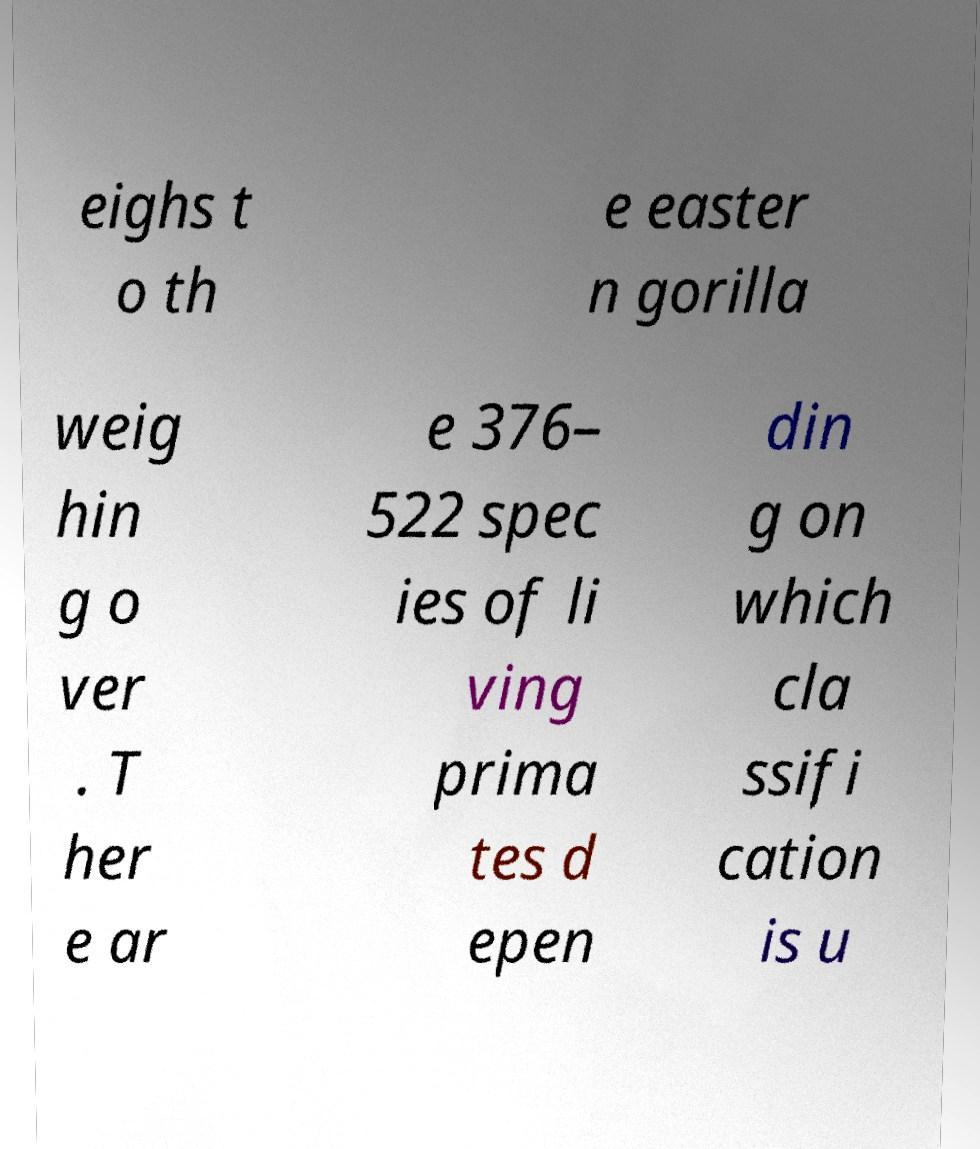Please identify and transcribe the text found in this image. eighs t o th e easter n gorilla weig hin g o ver . T her e ar e 376– 522 spec ies of li ving prima tes d epen din g on which cla ssifi cation is u 